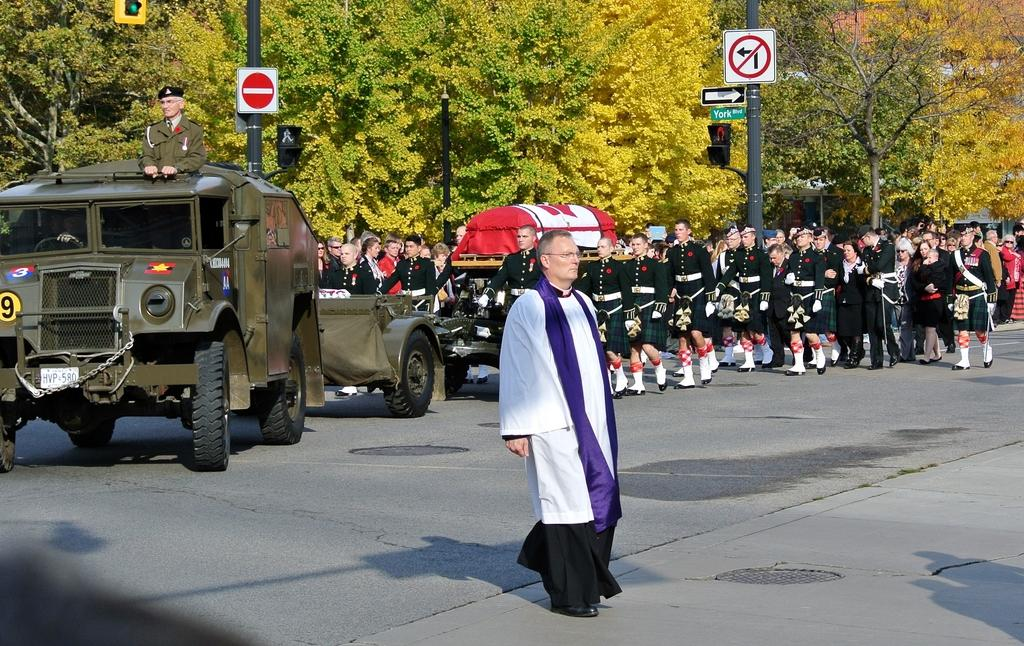What are the people in the image doing? The people in the image are standing on the road. Can you describe the person on the motor vehicle? There is a person standing on a motor vehicle in the image. What can be seen in the background of the image? In the background, there are sign boards, name boards, poles, and trees. What type of mask is the person on the motor vehicle wearing? There is no mask visible on the person standing on the motor vehicle in the image. What type of pleasure can be seen being experienced by the trees in the background? The trees in the background are not experiencing any pleasure, as they are inanimate objects. 